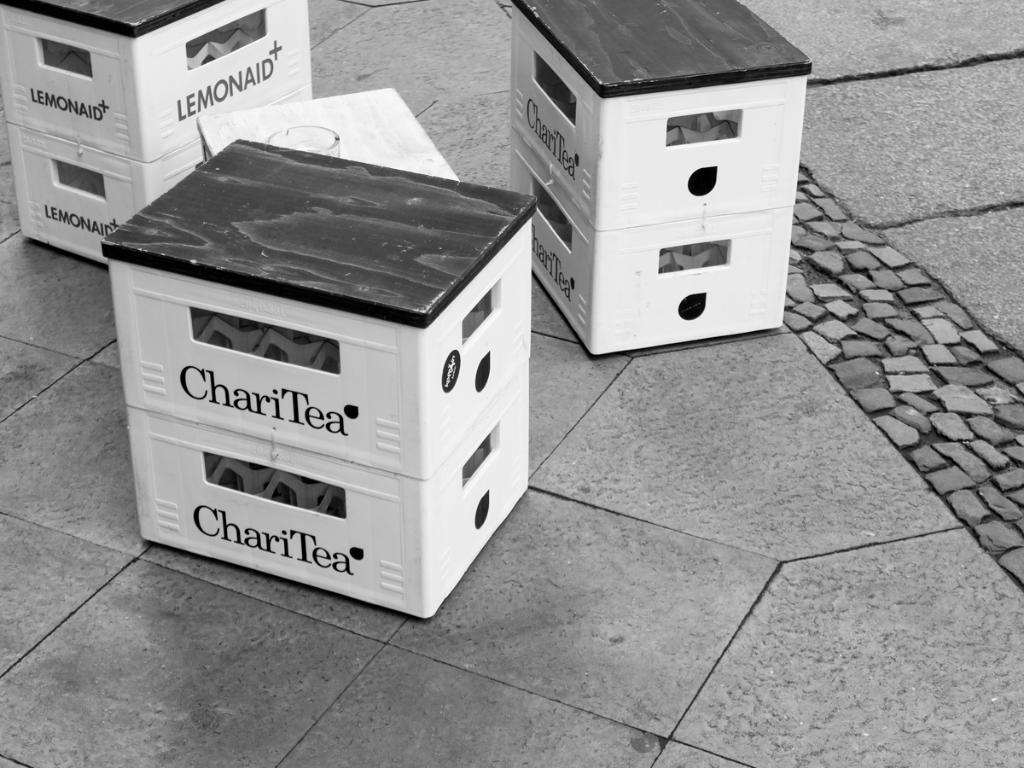Provide a one-sentence caption for the provided image. Three sets of containers are sitting on the ground, two of which are labeled as ChariTea. 